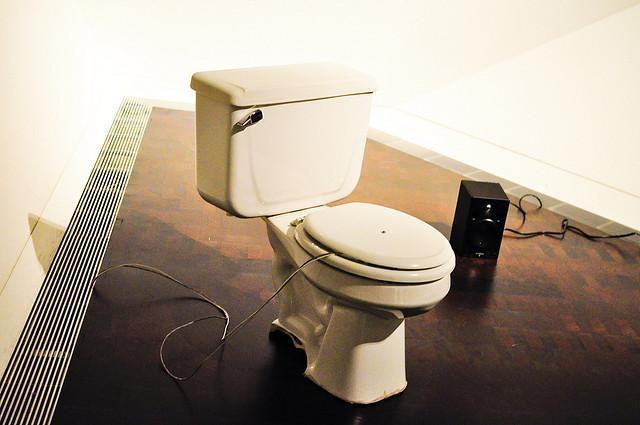How many women are pictured?
Give a very brief answer. 0. 